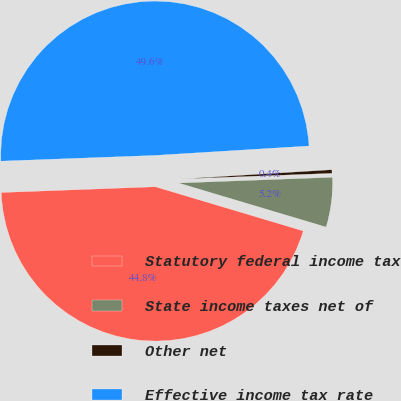Convert chart to OTSL. <chart><loc_0><loc_0><loc_500><loc_500><pie_chart><fcel>Statutory federal income tax<fcel>State income taxes net of<fcel>Other net<fcel>Effective income tax rate<nl><fcel>44.79%<fcel>5.21%<fcel>0.38%<fcel>49.62%<nl></chart> 